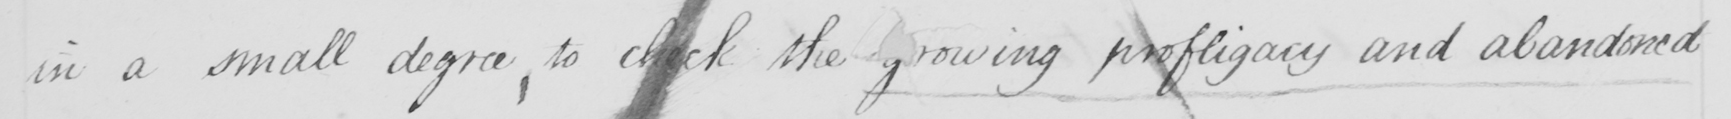Transcribe the text shown in this historical manuscript line. in a small degree, to check the growing profligacy and abandoned 